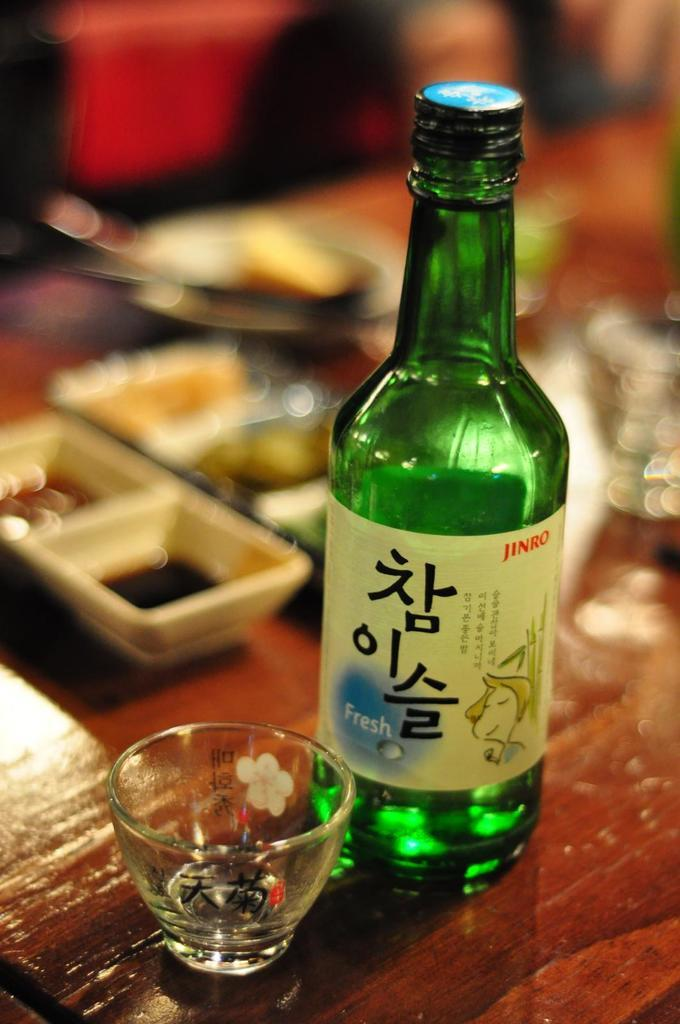Provide a one-sentence caption for the provided image. Jinro Beer bottle with a cup that is being served at a restaurant. 